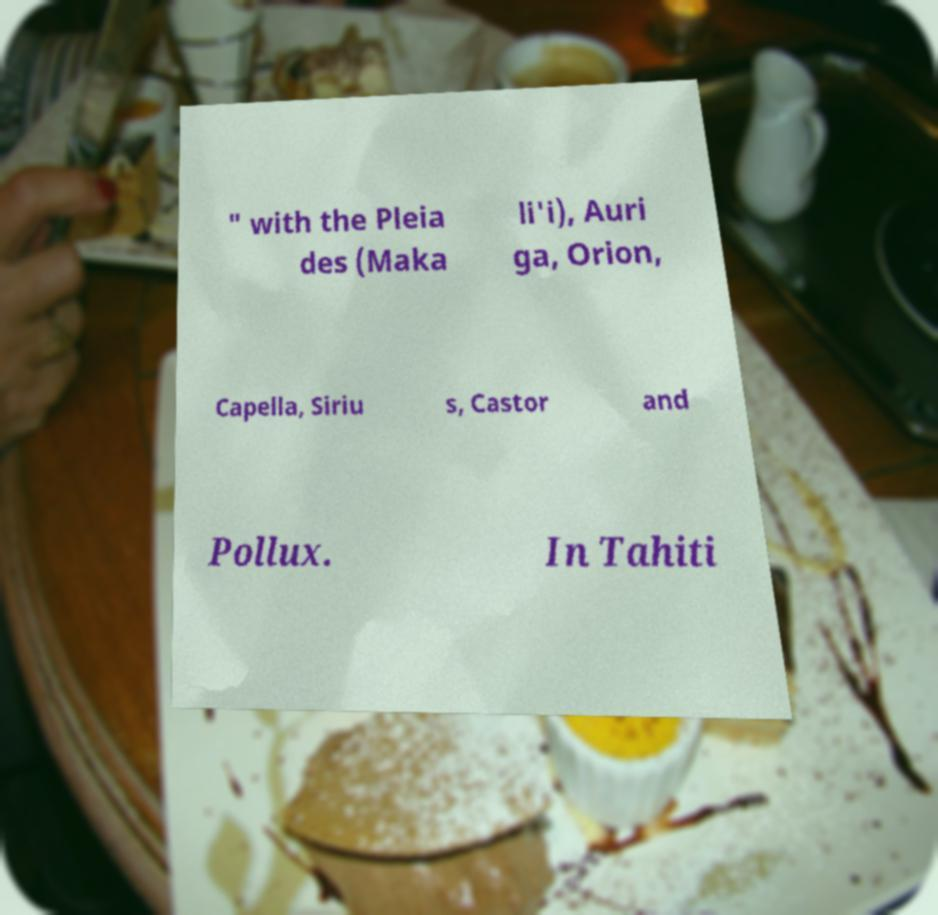What messages or text are displayed in this image? I need them in a readable, typed format. " with the Pleia des (Maka li'i), Auri ga, Orion, Capella, Siriu s, Castor and Pollux. In Tahiti 